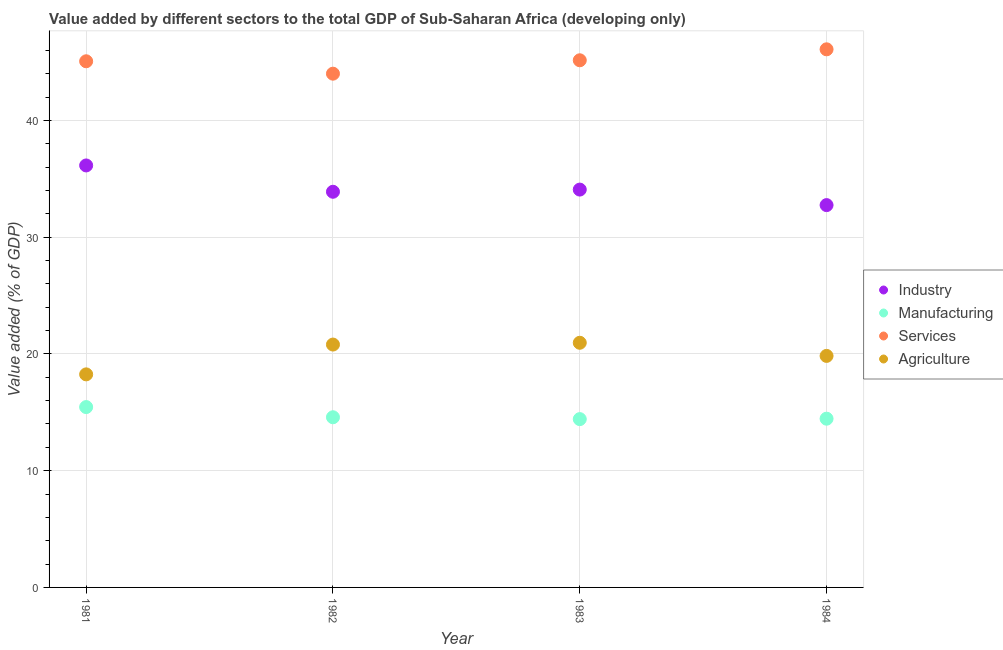What is the value added by manufacturing sector in 1981?
Ensure brevity in your answer.  15.45. Across all years, what is the maximum value added by manufacturing sector?
Provide a short and direct response. 15.45. Across all years, what is the minimum value added by manufacturing sector?
Provide a succinct answer. 14.42. What is the total value added by manufacturing sector in the graph?
Provide a succinct answer. 58.89. What is the difference between the value added by agricultural sector in 1981 and that in 1982?
Give a very brief answer. -2.55. What is the difference between the value added by services sector in 1981 and the value added by agricultural sector in 1983?
Provide a short and direct response. 24.11. What is the average value added by agricultural sector per year?
Your answer should be compact. 19.96. In the year 1984, what is the difference between the value added by manufacturing sector and value added by services sector?
Provide a succinct answer. -31.64. What is the ratio of the value added by industrial sector in 1983 to that in 1984?
Offer a terse response. 1.04. Is the value added by manufacturing sector in 1981 less than that in 1982?
Provide a succinct answer. No. Is the difference between the value added by industrial sector in 1983 and 1984 greater than the difference between the value added by agricultural sector in 1983 and 1984?
Your answer should be very brief. Yes. What is the difference between the highest and the second highest value added by services sector?
Ensure brevity in your answer.  0.94. What is the difference between the highest and the lowest value added by manufacturing sector?
Provide a succinct answer. 1.03. In how many years, is the value added by agricultural sector greater than the average value added by agricultural sector taken over all years?
Provide a succinct answer. 2. Is the sum of the value added by agricultural sector in 1981 and 1984 greater than the maximum value added by manufacturing sector across all years?
Your answer should be compact. Yes. Is it the case that in every year, the sum of the value added by industrial sector and value added by manufacturing sector is greater than the value added by services sector?
Provide a short and direct response. Yes. Does the value added by services sector monotonically increase over the years?
Your answer should be compact. No. Is the value added by services sector strictly less than the value added by agricultural sector over the years?
Provide a succinct answer. No. How many years are there in the graph?
Keep it short and to the point. 4. What is the difference between two consecutive major ticks on the Y-axis?
Offer a very short reply. 10. Does the graph contain grids?
Ensure brevity in your answer.  Yes. Where does the legend appear in the graph?
Provide a short and direct response. Center right. How many legend labels are there?
Ensure brevity in your answer.  4. How are the legend labels stacked?
Make the answer very short. Vertical. What is the title of the graph?
Ensure brevity in your answer.  Value added by different sectors to the total GDP of Sub-Saharan Africa (developing only). What is the label or title of the Y-axis?
Ensure brevity in your answer.  Value added (% of GDP). What is the Value added (% of GDP) in Industry in 1981?
Your answer should be very brief. 36.15. What is the Value added (% of GDP) of Manufacturing in 1981?
Ensure brevity in your answer.  15.45. What is the Value added (% of GDP) of Services in 1981?
Provide a short and direct response. 45.07. What is the Value added (% of GDP) in Agriculture in 1981?
Provide a succinct answer. 18.25. What is the Value added (% of GDP) in Industry in 1982?
Provide a short and direct response. 33.89. What is the Value added (% of GDP) of Manufacturing in 1982?
Provide a succinct answer. 14.58. What is the Value added (% of GDP) of Services in 1982?
Offer a very short reply. 44.01. What is the Value added (% of GDP) of Agriculture in 1982?
Provide a succinct answer. 20.8. What is the Value added (% of GDP) in Industry in 1983?
Your answer should be compact. 34.08. What is the Value added (% of GDP) of Manufacturing in 1983?
Keep it short and to the point. 14.42. What is the Value added (% of GDP) of Services in 1983?
Your response must be concise. 45.15. What is the Value added (% of GDP) in Agriculture in 1983?
Your answer should be very brief. 20.96. What is the Value added (% of GDP) in Industry in 1984?
Your response must be concise. 32.75. What is the Value added (% of GDP) in Manufacturing in 1984?
Offer a terse response. 14.45. What is the Value added (% of GDP) of Services in 1984?
Provide a short and direct response. 46.09. What is the Value added (% of GDP) of Agriculture in 1984?
Offer a very short reply. 19.83. Across all years, what is the maximum Value added (% of GDP) in Industry?
Ensure brevity in your answer.  36.15. Across all years, what is the maximum Value added (% of GDP) in Manufacturing?
Your response must be concise. 15.45. Across all years, what is the maximum Value added (% of GDP) of Services?
Your answer should be compact. 46.09. Across all years, what is the maximum Value added (% of GDP) of Agriculture?
Provide a short and direct response. 20.96. Across all years, what is the minimum Value added (% of GDP) of Industry?
Your answer should be compact. 32.75. Across all years, what is the minimum Value added (% of GDP) of Manufacturing?
Ensure brevity in your answer.  14.42. Across all years, what is the minimum Value added (% of GDP) in Services?
Offer a very short reply. 44.01. Across all years, what is the minimum Value added (% of GDP) of Agriculture?
Your response must be concise. 18.25. What is the total Value added (% of GDP) of Industry in the graph?
Your answer should be very brief. 136.86. What is the total Value added (% of GDP) in Manufacturing in the graph?
Offer a terse response. 58.89. What is the total Value added (% of GDP) in Services in the graph?
Ensure brevity in your answer.  180.32. What is the total Value added (% of GDP) of Agriculture in the graph?
Provide a short and direct response. 79.84. What is the difference between the Value added (% of GDP) of Industry in 1981 and that in 1982?
Your answer should be very brief. 2.25. What is the difference between the Value added (% of GDP) in Manufacturing in 1981 and that in 1982?
Give a very brief answer. 0.87. What is the difference between the Value added (% of GDP) in Services in 1981 and that in 1982?
Keep it short and to the point. 1.06. What is the difference between the Value added (% of GDP) in Agriculture in 1981 and that in 1982?
Ensure brevity in your answer.  -2.55. What is the difference between the Value added (% of GDP) in Industry in 1981 and that in 1983?
Provide a succinct answer. 2.07. What is the difference between the Value added (% of GDP) in Manufacturing in 1981 and that in 1983?
Provide a short and direct response. 1.03. What is the difference between the Value added (% of GDP) in Services in 1981 and that in 1983?
Your response must be concise. -0.09. What is the difference between the Value added (% of GDP) of Agriculture in 1981 and that in 1983?
Offer a very short reply. -2.71. What is the difference between the Value added (% of GDP) in Industry in 1981 and that in 1984?
Ensure brevity in your answer.  3.4. What is the difference between the Value added (% of GDP) in Services in 1981 and that in 1984?
Make the answer very short. -1.02. What is the difference between the Value added (% of GDP) of Agriculture in 1981 and that in 1984?
Give a very brief answer. -1.58. What is the difference between the Value added (% of GDP) of Industry in 1982 and that in 1983?
Your answer should be compact. -0.19. What is the difference between the Value added (% of GDP) in Manufacturing in 1982 and that in 1983?
Offer a terse response. 0.16. What is the difference between the Value added (% of GDP) in Services in 1982 and that in 1983?
Offer a very short reply. -1.15. What is the difference between the Value added (% of GDP) in Agriculture in 1982 and that in 1983?
Your answer should be compact. -0.15. What is the difference between the Value added (% of GDP) in Industry in 1982 and that in 1984?
Ensure brevity in your answer.  1.14. What is the difference between the Value added (% of GDP) of Manufacturing in 1982 and that in 1984?
Give a very brief answer. 0.12. What is the difference between the Value added (% of GDP) in Services in 1982 and that in 1984?
Provide a succinct answer. -2.09. What is the difference between the Value added (% of GDP) in Agriculture in 1982 and that in 1984?
Keep it short and to the point. 0.97. What is the difference between the Value added (% of GDP) of Industry in 1983 and that in 1984?
Provide a succinct answer. 1.33. What is the difference between the Value added (% of GDP) of Manufacturing in 1983 and that in 1984?
Make the answer very short. -0.04. What is the difference between the Value added (% of GDP) in Services in 1983 and that in 1984?
Make the answer very short. -0.94. What is the difference between the Value added (% of GDP) in Agriculture in 1983 and that in 1984?
Your answer should be very brief. 1.13. What is the difference between the Value added (% of GDP) in Industry in 1981 and the Value added (% of GDP) in Manufacturing in 1982?
Make the answer very short. 21.57. What is the difference between the Value added (% of GDP) of Industry in 1981 and the Value added (% of GDP) of Services in 1982?
Your response must be concise. -7.86. What is the difference between the Value added (% of GDP) of Industry in 1981 and the Value added (% of GDP) of Agriculture in 1982?
Offer a very short reply. 15.34. What is the difference between the Value added (% of GDP) in Manufacturing in 1981 and the Value added (% of GDP) in Services in 1982?
Offer a very short reply. -28.56. What is the difference between the Value added (% of GDP) of Manufacturing in 1981 and the Value added (% of GDP) of Agriculture in 1982?
Your answer should be compact. -5.35. What is the difference between the Value added (% of GDP) of Services in 1981 and the Value added (% of GDP) of Agriculture in 1982?
Your answer should be compact. 24.27. What is the difference between the Value added (% of GDP) of Industry in 1981 and the Value added (% of GDP) of Manufacturing in 1983?
Offer a terse response. 21.73. What is the difference between the Value added (% of GDP) of Industry in 1981 and the Value added (% of GDP) of Services in 1983?
Offer a terse response. -9.01. What is the difference between the Value added (% of GDP) of Industry in 1981 and the Value added (% of GDP) of Agriculture in 1983?
Your answer should be very brief. 15.19. What is the difference between the Value added (% of GDP) of Manufacturing in 1981 and the Value added (% of GDP) of Services in 1983?
Offer a very short reply. -29.71. What is the difference between the Value added (% of GDP) in Manufacturing in 1981 and the Value added (% of GDP) in Agriculture in 1983?
Your response must be concise. -5.51. What is the difference between the Value added (% of GDP) of Services in 1981 and the Value added (% of GDP) of Agriculture in 1983?
Your answer should be very brief. 24.11. What is the difference between the Value added (% of GDP) in Industry in 1981 and the Value added (% of GDP) in Manufacturing in 1984?
Offer a very short reply. 21.69. What is the difference between the Value added (% of GDP) of Industry in 1981 and the Value added (% of GDP) of Services in 1984?
Your answer should be very brief. -9.95. What is the difference between the Value added (% of GDP) in Industry in 1981 and the Value added (% of GDP) in Agriculture in 1984?
Provide a succinct answer. 16.31. What is the difference between the Value added (% of GDP) of Manufacturing in 1981 and the Value added (% of GDP) of Services in 1984?
Ensure brevity in your answer.  -30.64. What is the difference between the Value added (% of GDP) in Manufacturing in 1981 and the Value added (% of GDP) in Agriculture in 1984?
Provide a succinct answer. -4.38. What is the difference between the Value added (% of GDP) of Services in 1981 and the Value added (% of GDP) of Agriculture in 1984?
Give a very brief answer. 25.24. What is the difference between the Value added (% of GDP) of Industry in 1982 and the Value added (% of GDP) of Manufacturing in 1983?
Provide a short and direct response. 19.47. What is the difference between the Value added (% of GDP) of Industry in 1982 and the Value added (% of GDP) of Services in 1983?
Keep it short and to the point. -11.26. What is the difference between the Value added (% of GDP) in Industry in 1982 and the Value added (% of GDP) in Agriculture in 1983?
Ensure brevity in your answer.  12.93. What is the difference between the Value added (% of GDP) in Manufacturing in 1982 and the Value added (% of GDP) in Services in 1983?
Your response must be concise. -30.58. What is the difference between the Value added (% of GDP) of Manufacturing in 1982 and the Value added (% of GDP) of Agriculture in 1983?
Your answer should be compact. -6.38. What is the difference between the Value added (% of GDP) of Services in 1982 and the Value added (% of GDP) of Agriculture in 1983?
Your answer should be very brief. 23.05. What is the difference between the Value added (% of GDP) in Industry in 1982 and the Value added (% of GDP) in Manufacturing in 1984?
Offer a very short reply. 19.44. What is the difference between the Value added (% of GDP) of Industry in 1982 and the Value added (% of GDP) of Services in 1984?
Ensure brevity in your answer.  -12.2. What is the difference between the Value added (% of GDP) of Industry in 1982 and the Value added (% of GDP) of Agriculture in 1984?
Your answer should be compact. 14.06. What is the difference between the Value added (% of GDP) in Manufacturing in 1982 and the Value added (% of GDP) in Services in 1984?
Your answer should be very brief. -31.52. What is the difference between the Value added (% of GDP) in Manufacturing in 1982 and the Value added (% of GDP) in Agriculture in 1984?
Offer a very short reply. -5.26. What is the difference between the Value added (% of GDP) of Services in 1982 and the Value added (% of GDP) of Agriculture in 1984?
Give a very brief answer. 24.17. What is the difference between the Value added (% of GDP) of Industry in 1983 and the Value added (% of GDP) of Manufacturing in 1984?
Ensure brevity in your answer.  19.62. What is the difference between the Value added (% of GDP) of Industry in 1983 and the Value added (% of GDP) of Services in 1984?
Your answer should be compact. -12.02. What is the difference between the Value added (% of GDP) of Industry in 1983 and the Value added (% of GDP) of Agriculture in 1984?
Your answer should be compact. 14.25. What is the difference between the Value added (% of GDP) in Manufacturing in 1983 and the Value added (% of GDP) in Services in 1984?
Ensure brevity in your answer.  -31.67. What is the difference between the Value added (% of GDP) of Manufacturing in 1983 and the Value added (% of GDP) of Agriculture in 1984?
Your answer should be very brief. -5.41. What is the difference between the Value added (% of GDP) in Services in 1983 and the Value added (% of GDP) in Agriculture in 1984?
Keep it short and to the point. 25.32. What is the average Value added (% of GDP) in Industry per year?
Provide a short and direct response. 34.22. What is the average Value added (% of GDP) of Manufacturing per year?
Provide a succinct answer. 14.72. What is the average Value added (% of GDP) of Services per year?
Your answer should be very brief. 45.08. What is the average Value added (% of GDP) in Agriculture per year?
Keep it short and to the point. 19.96. In the year 1981, what is the difference between the Value added (% of GDP) of Industry and Value added (% of GDP) of Manufacturing?
Your answer should be compact. 20.7. In the year 1981, what is the difference between the Value added (% of GDP) of Industry and Value added (% of GDP) of Services?
Offer a very short reply. -8.92. In the year 1981, what is the difference between the Value added (% of GDP) of Industry and Value added (% of GDP) of Agriculture?
Provide a succinct answer. 17.9. In the year 1981, what is the difference between the Value added (% of GDP) of Manufacturing and Value added (% of GDP) of Services?
Provide a short and direct response. -29.62. In the year 1981, what is the difference between the Value added (% of GDP) of Manufacturing and Value added (% of GDP) of Agriculture?
Provide a short and direct response. -2.8. In the year 1981, what is the difference between the Value added (% of GDP) in Services and Value added (% of GDP) in Agriculture?
Give a very brief answer. 26.82. In the year 1982, what is the difference between the Value added (% of GDP) in Industry and Value added (% of GDP) in Manufacturing?
Your response must be concise. 19.31. In the year 1982, what is the difference between the Value added (% of GDP) of Industry and Value added (% of GDP) of Services?
Give a very brief answer. -10.12. In the year 1982, what is the difference between the Value added (% of GDP) of Industry and Value added (% of GDP) of Agriculture?
Ensure brevity in your answer.  13.09. In the year 1982, what is the difference between the Value added (% of GDP) of Manufacturing and Value added (% of GDP) of Services?
Your answer should be very brief. -29.43. In the year 1982, what is the difference between the Value added (% of GDP) in Manufacturing and Value added (% of GDP) in Agriculture?
Make the answer very short. -6.23. In the year 1982, what is the difference between the Value added (% of GDP) in Services and Value added (% of GDP) in Agriculture?
Offer a terse response. 23.2. In the year 1983, what is the difference between the Value added (% of GDP) of Industry and Value added (% of GDP) of Manufacturing?
Give a very brief answer. 19.66. In the year 1983, what is the difference between the Value added (% of GDP) in Industry and Value added (% of GDP) in Services?
Offer a terse response. -11.08. In the year 1983, what is the difference between the Value added (% of GDP) in Industry and Value added (% of GDP) in Agriculture?
Give a very brief answer. 13.12. In the year 1983, what is the difference between the Value added (% of GDP) in Manufacturing and Value added (% of GDP) in Services?
Give a very brief answer. -30.74. In the year 1983, what is the difference between the Value added (% of GDP) in Manufacturing and Value added (% of GDP) in Agriculture?
Keep it short and to the point. -6.54. In the year 1983, what is the difference between the Value added (% of GDP) in Services and Value added (% of GDP) in Agriculture?
Your answer should be compact. 24.2. In the year 1984, what is the difference between the Value added (% of GDP) of Industry and Value added (% of GDP) of Manufacturing?
Your answer should be very brief. 18.29. In the year 1984, what is the difference between the Value added (% of GDP) in Industry and Value added (% of GDP) in Services?
Your answer should be compact. -13.34. In the year 1984, what is the difference between the Value added (% of GDP) of Industry and Value added (% of GDP) of Agriculture?
Your response must be concise. 12.92. In the year 1984, what is the difference between the Value added (% of GDP) in Manufacturing and Value added (% of GDP) in Services?
Provide a short and direct response. -31.64. In the year 1984, what is the difference between the Value added (% of GDP) of Manufacturing and Value added (% of GDP) of Agriculture?
Your response must be concise. -5.38. In the year 1984, what is the difference between the Value added (% of GDP) of Services and Value added (% of GDP) of Agriculture?
Ensure brevity in your answer.  26.26. What is the ratio of the Value added (% of GDP) of Industry in 1981 to that in 1982?
Provide a short and direct response. 1.07. What is the ratio of the Value added (% of GDP) in Manufacturing in 1981 to that in 1982?
Your answer should be very brief. 1.06. What is the ratio of the Value added (% of GDP) of Services in 1981 to that in 1982?
Offer a terse response. 1.02. What is the ratio of the Value added (% of GDP) in Agriculture in 1981 to that in 1982?
Make the answer very short. 0.88. What is the ratio of the Value added (% of GDP) in Industry in 1981 to that in 1983?
Your answer should be compact. 1.06. What is the ratio of the Value added (% of GDP) in Manufacturing in 1981 to that in 1983?
Your answer should be compact. 1.07. What is the ratio of the Value added (% of GDP) in Services in 1981 to that in 1983?
Keep it short and to the point. 1. What is the ratio of the Value added (% of GDP) in Agriculture in 1981 to that in 1983?
Provide a short and direct response. 0.87. What is the ratio of the Value added (% of GDP) of Industry in 1981 to that in 1984?
Your answer should be very brief. 1.1. What is the ratio of the Value added (% of GDP) in Manufacturing in 1981 to that in 1984?
Give a very brief answer. 1.07. What is the ratio of the Value added (% of GDP) of Services in 1981 to that in 1984?
Provide a succinct answer. 0.98. What is the ratio of the Value added (% of GDP) of Agriculture in 1981 to that in 1984?
Offer a very short reply. 0.92. What is the ratio of the Value added (% of GDP) of Services in 1982 to that in 1983?
Provide a short and direct response. 0.97. What is the ratio of the Value added (% of GDP) of Industry in 1982 to that in 1984?
Give a very brief answer. 1.03. What is the ratio of the Value added (% of GDP) of Manufacturing in 1982 to that in 1984?
Your answer should be compact. 1.01. What is the ratio of the Value added (% of GDP) in Services in 1982 to that in 1984?
Your answer should be compact. 0.95. What is the ratio of the Value added (% of GDP) in Agriculture in 1982 to that in 1984?
Your answer should be very brief. 1.05. What is the ratio of the Value added (% of GDP) of Industry in 1983 to that in 1984?
Your answer should be compact. 1.04. What is the ratio of the Value added (% of GDP) of Manufacturing in 1983 to that in 1984?
Your answer should be compact. 1. What is the ratio of the Value added (% of GDP) of Services in 1983 to that in 1984?
Keep it short and to the point. 0.98. What is the ratio of the Value added (% of GDP) of Agriculture in 1983 to that in 1984?
Give a very brief answer. 1.06. What is the difference between the highest and the second highest Value added (% of GDP) of Industry?
Keep it short and to the point. 2.07. What is the difference between the highest and the second highest Value added (% of GDP) in Manufacturing?
Ensure brevity in your answer.  0.87. What is the difference between the highest and the second highest Value added (% of GDP) of Services?
Ensure brevity in your answer.  0.94. What is the difference between the highest and the second highest Value added (% of GDP) of Agriculture?
Provide a short and direct response. 0.15. What is the difference between the highest and the lowest Value added (% of GDP) of Industry?
Make the answer very short. 3.4. What is the difference between the highest and the lowest Value added (% of GDP) in Manufacturing?
Your answer should be compact. 1.03. What is the difference between the highest and the lowest Value added (% of GDP) in Services?
Your answer should be compact. 2.09. What is the difference between the highest and the lowest Value added (% of GDP) of Agriculture?
Your response must be concise. 2.71. 